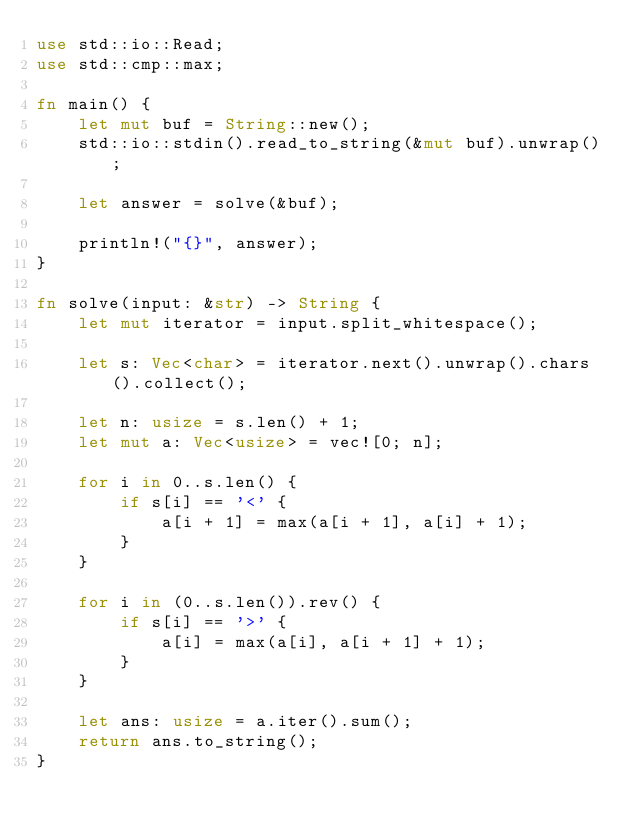Convert code to text. <code><loc_0><loc_0><loc_500><loc_500><_Rust_>use std::io::Read;
use std::cmp::max;

fn main() {
    let mut buf = String::new();
    std::io::stdin().read_to_string(&mut buf).unwrap();

    let answer = solve(&buf);

    println!("{}", answer);
}

fn solve(input: &str) -> String {
    let mut iterator = input.split_whitespace();

    let s: Vec<char> = iterator.next().unwrap().chars().collect();

    let n: usize = s.len() + 1;
    let mut a: Vec<usize> = vec![0; n];

    for i in 0..s.len() {
        if s[i] == '<' {
            a[i + 1] = max(a[i + 1], a[i] + 1);
        }
    }

    for i in (0..s.len()).rev() {
        if s[i] == '>' {
            a[i] = max(a[i], a[i + 1] + 1);
        }
    }

    let ans: usize = a.iter().sum();
    return ans.to_string();
}
</code> 